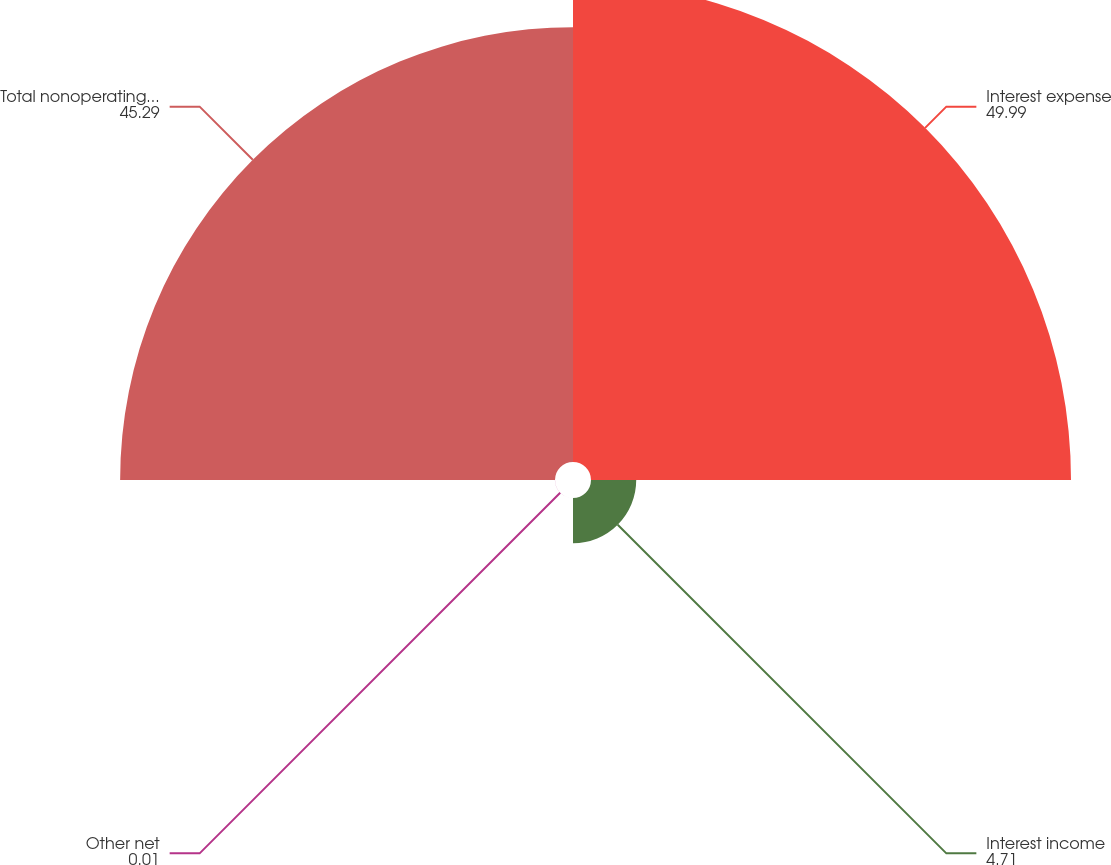Convert chart. <chart><loc_0><loc_0><loc_500><loc_500><pie_chart><fcel>Interest expense<fcel>Interest income<fcel>Other net<fcel>Total nonoperating expenses<nl><fcel>49.99%<fcel>4.71%<fcel>0.01%<fcel>45.29%<nl></chart> 